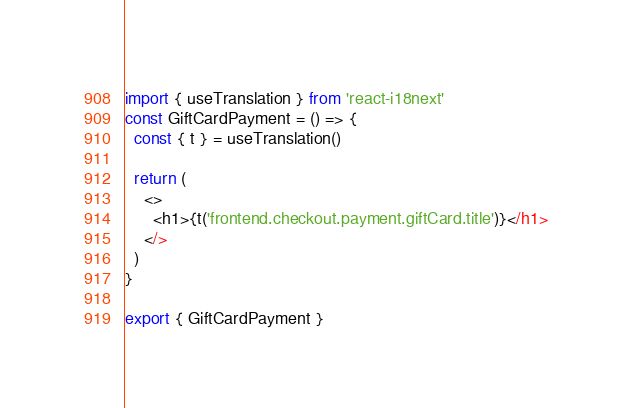Convert code to text. <code><loc_0><loc_0><loc_500><loc_500><_JavaScript_>import { useTranslation } from 'react-i18next'
const GiftCardPayment = () => {
  const { t } = useTranslation()

  return (
    <>
      <h1>{t('frontend.checkout.payment.giftCard.title')}</h1>
    </>
  )
}

export { GiftCardPayment }
</code> 